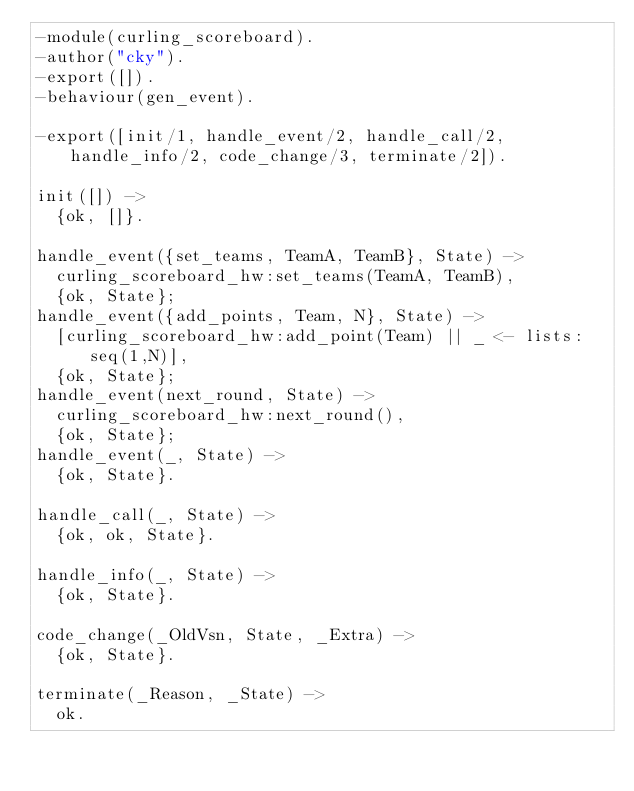<code> <loc_0><loc_0><loc_500><loc_500><_Erlang_>-module(curling_scoreboard).
-author("cky").
-export([]).
-behaviour(gen_event).

-export([init/1, handle_event/2, handle_call/2, handle_info/2, code_change/3, terminate/2]).

init([]) ->
  {ok, []}.

handle_event({set_teams, TeamA, TeamB}, State) ->
  curling_scoreboard_hw:set_teams(TeamA, TeamB),
  {ok, State};
handle_event({add_points, Team, N}, State) ->
  [curling_scoreboard_hw:add_point(Team) || _ <- lists:seq(1,N)],
  {ok, State};
handle_event(next_round, State) ->
  curling_scoreboard_hw:next_round(),
  {ok, State};
handle_event(_, State) ->
  {ok, State}.

handle_call(_, State) ->
  {ok, ok, State}.

handle_info(_, State) ->
  {ok, State}.

code_change(_OldVsn, State, _Extra) ->
  {ok, State}.

terminate(_Reason, _State) ->
  ok.</code> 